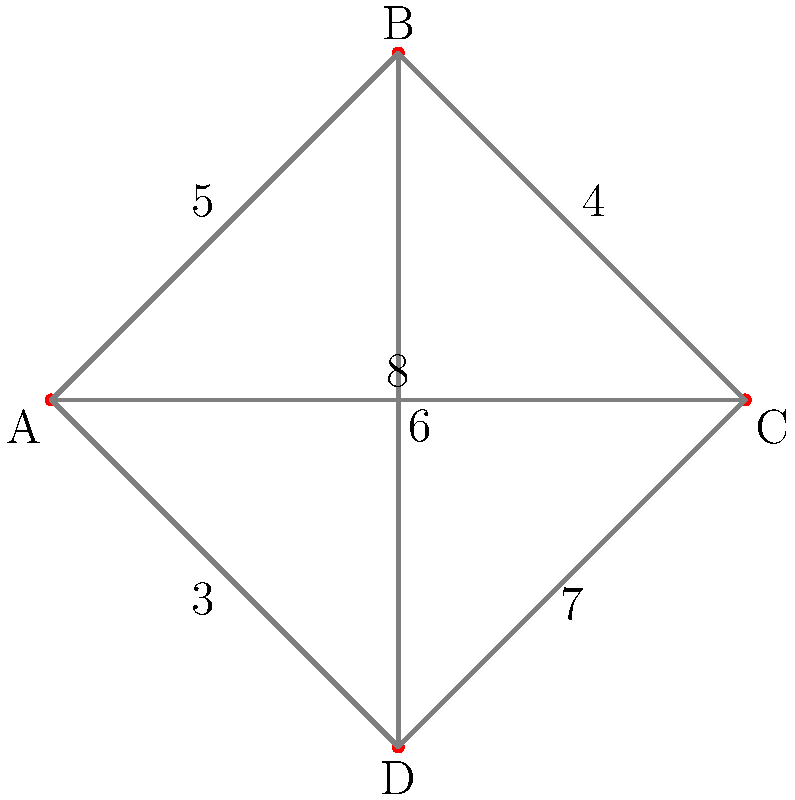Given the regional map where nodes represent cities and edges represent smuggling routes with associated risk levels, what is the minimum total risk level for a smuggling operation from city A to city C? To find the minimum total risk level from A to C, we need to consider all possible paths and their cumulative risk levels:

1. Direct route A to C:
   A → C = 8

2. Route through B:
   A → B → C = 5 + 4 = 9

3. Route through D:
   A → D → C = 3 + 7 = 10

4. Route through B and D:
   A → B → D → C = 5 + 6 + 7 = 18
   A → D → B → C = 3 + 6 + 4 = 13

The minimum risk level is the smallest value among these options, which is 8, corresponding to the direct route from A to C.
Answer: 8 